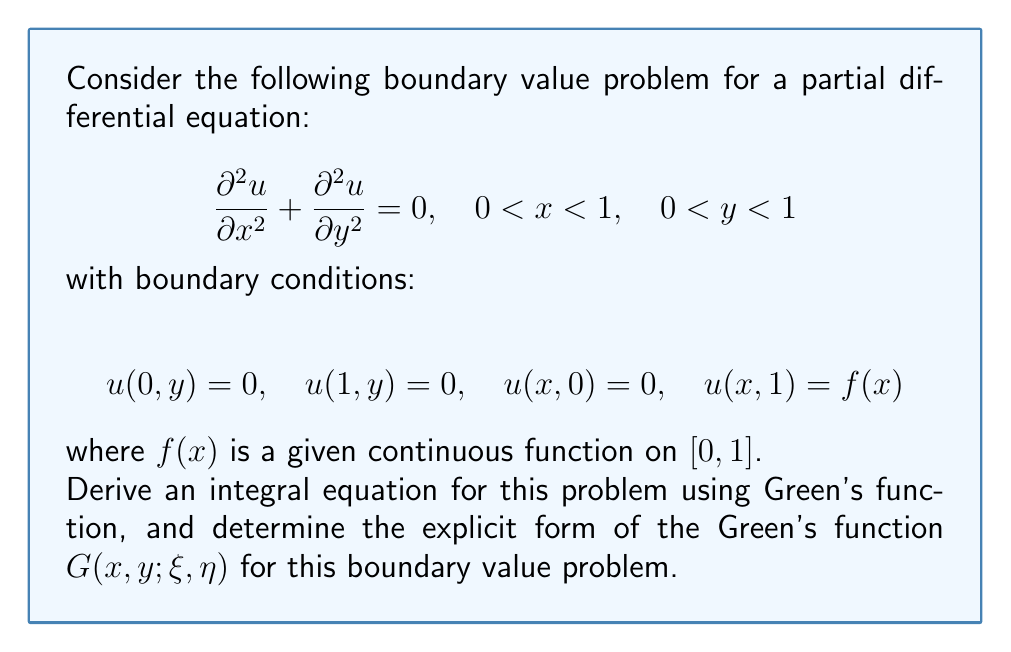What is the answer to this math problem? To solve this problem, we'll follow these steps:

1) First, we need to find the Green's function for this problem. The Green's function for the 2D Laplace equation in a rectangle with homogeneous Dirichlet boundary conditions on three sides is:

   $$G(x,y;\xi,\eta) = \frac{2}{\pi}\sum_{n=1}^{\infty} \frac{\sin(n\pi x)\sin(n\pi \xi)}{n\sinh(n\pi)} \sinh(n\pi y)\sinh(n\pi(1-\eta))$$

   for $y < \eta$, and

   $$G(x,y;\xi,\eta) = \frac{2}{\pi}\sum_{n=1}^{\infty} \frac{\sin(n\pi x)\sin(n\pi \xi)}{n\sinh(n\pi)} \sinh(n\pi \eta)\sinh(n\pi(1-y))$$

   for $y > \eta$.

2) The solution to our boundary value problem can be expressed using this Green's function as:

   $$u(x,y) = \int_0^1 G(x,y;\xi,1)f(\xi)d\xi$$

3) Substituting the Green's function for $y < 1$ (since we're evaluating at the top boundary where $\eta = 1$):

   $$u(x,y) = \int_0^1 \frac{2}{\pi}\sum_{n=1}^{\infty} \frac{\sin(n\pi x)\sin(n\pi \xi)}{n\sinh(n\pi)} \sinh(n\pi y)f(\xi)d\xi$$

4) This is our integral equation. It relates the unknown function $u(x,y)$ to the known boundary function $f(x)$ through an integral involving the Green's function.

5) To verify, we can check that this solution satisfies the boundary conditions:
   - At $x = 0$ and $x = 1$, $\sin(n\pi x) = 0$, so $u(0,y) = u(1,y) = 0$
   - At $y = 0$, $\sinh(n\pi y) = 0$, so $u(x,0) = 0$
   - At $y = 1$, $\sinh(n\pi y) = \sinh(n\pi)$, so the equation reduces to the Fourier series of $f(x)$

Thus, we have derived the integral equation and determined the explicit form of the Green's function for this boundary value problem.
Answer: $u(x,y) = \int_0^1 \frac{2}{\pi}\sum_{n=1}^{\infty} \frac{\sin(n\pi x)\sin(n\pi \xi)}{n\sinh(n\pi)} \sinh(n\pi y)f(\xi)d\xi$ 